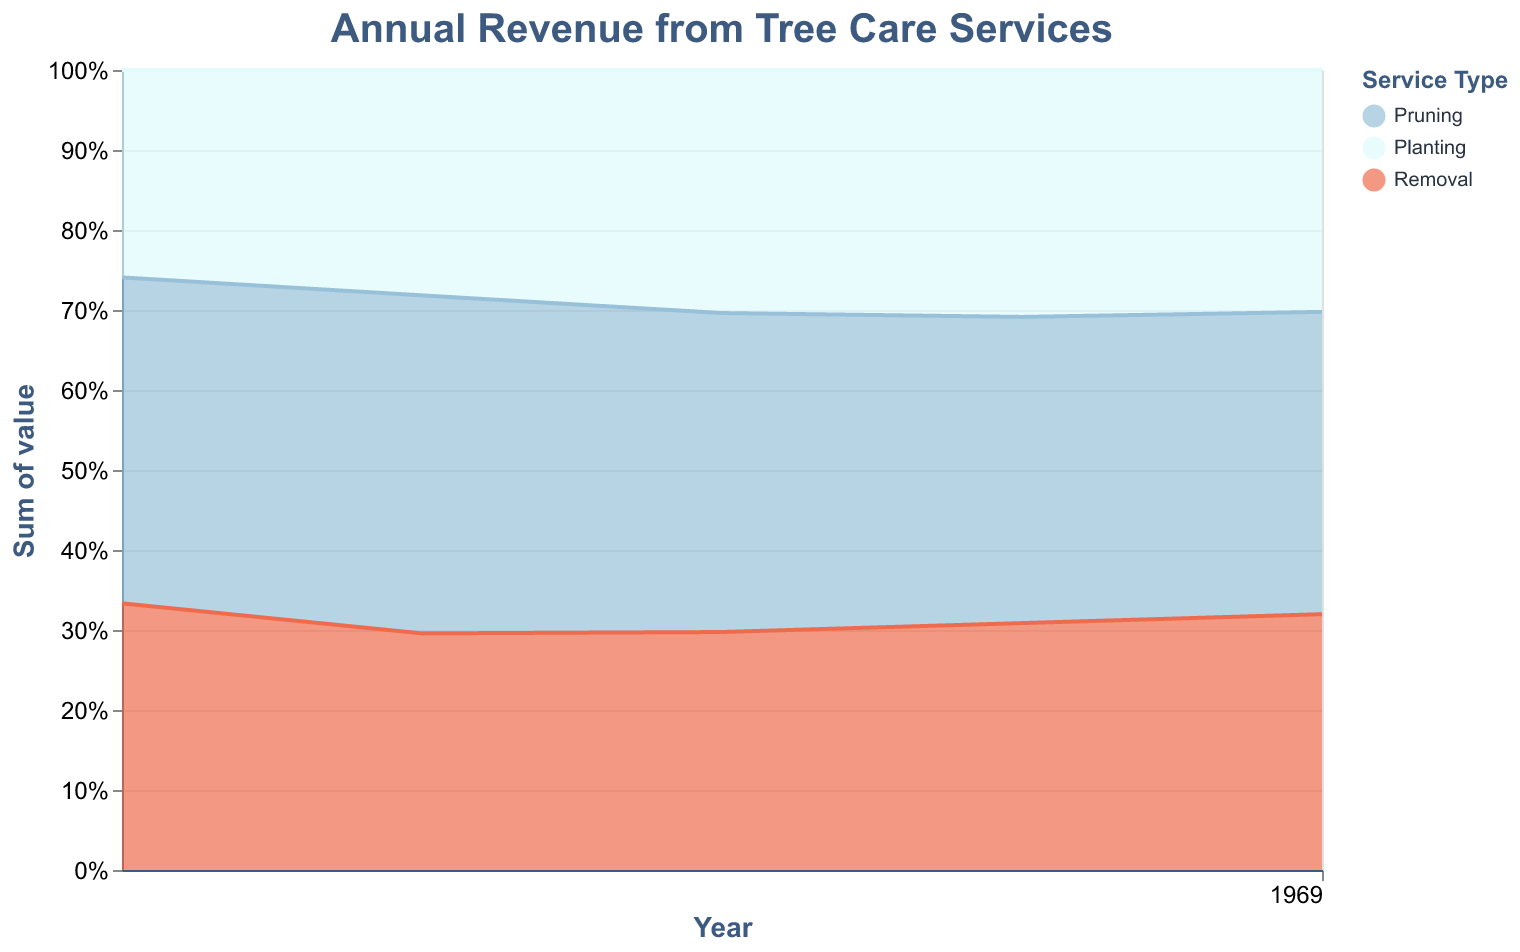Which service type contributed the most to the revenue in 2018? Looking at the segment sizes in the 2018 portion of the chart, the "Pruning" service appears to have the largest area relative to "Planting" and "Removal".
Answer: Pruning How did the overall revenue distribution between the different services change from 2018 to 2022? Observe the changes in segment sizes over the years. "Pruning" has seen a consistent increase. "Planting" and "Removal" segments have also grown, but "Removal" grew at a faster rate compared to "Planting".
Answer: All services increased, with "Pruning" consistently high. "Removal" increased more significantly than "Planting" Which year saw the highest combined revenue from all services? To find the highest combined revenue, sum up the normalized segment heights for each year. 2022 has the largest combined height at its peak.
Answer: 2022 Compare the revenue proportions of Pruning and Planting in 2020. Which was higher? By comparing the areas, "Pruning" takes up a larger vertical space than "Planting" in the portion of the chart corresponding to 2020.
Answer: Pruning What percentage of the total revenue did Planting represent in 2021? In 2021, the "Planting" segment, visually estimated to represent around 33% of the total stacked area, makes up roughly one-third.
Answer: Approximately 33% Which service type showed a consistent increase every year? Analyzing the trend lines for each service, "Pruning" and "Planting" show consistent growth, but "Planting" increased every single year without fluctuation.
Answer: Planting In 2019, did Removal contribute more or less to the revenue compared to Planting? Comparing the areas dedicated to these services for 2019, "Removal" has a slightly smaller segment than "Planting".
Answer: Less By what approximate amount did the revenue from Pruning increase between 2018 and 2022? The 2018 value for Pruning is 55,000, and in 2022 it is 65,000. Thus, the increase is 65,000 - 55,000 = 10,000.
Answer: 10,000 Is there any service that saw a decline in revenue in any year? By observing the trends of each service, we see that "Pruning" revenue slightly decreased from 2020 to 2021.
Answer: Pruning How does the total revenue in 2022 compare to that in 2018? Summing up the total revenues for all services in 2018 and 2022, the combined revenue in 2018 is 55,000 + 35,000 + 45,000 = 135,000, while in 2022 it is 65,000 + 52,000 + 55,000 = 172,000. Therefore, 2022's revenue is higher by 172,000 - 135,000 = 37,000.
Answer: 37,000 